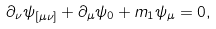<formula> <loc_0><loc_0><loc_500><loc_500>\partial _ { \nu } \psi _ { [ \mu \nu ] } + \partial _ { \mu } \psi _ { 0 } + m _ { 1 } \psi _ { \mu } = 0 ,</formula> 